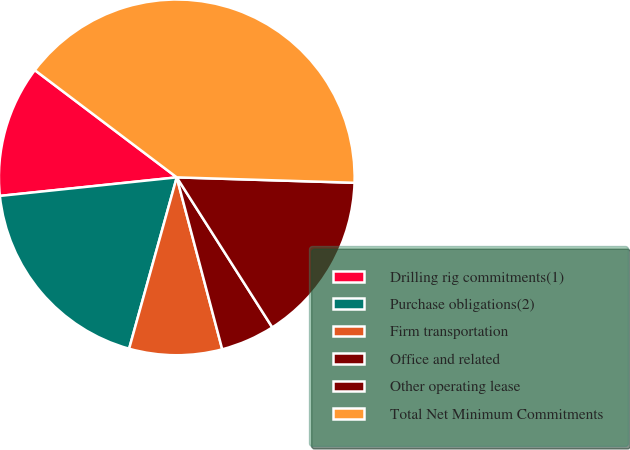Convert chart to OTSL. <chart><loc_0><loc_0><loc_500><loc_500><pie_chart><fcel>Drilling rig commitments(1)<fcel>Purchase obligations(2)<fcel>Firm transportation<fcel>Office and related<fcel>Other operating lease<fcel>Total Net Minimum Commitments<nl><fcel>11.96%<fcel>19.02%<fcel>8.43%<fcel>4.91%<fcel>15.49%<fcel>40.19%<nl></chart> 